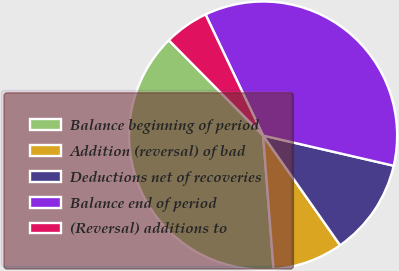Convert chart. <chart><loc_0><loc_0><loc_500><loc_500><pie_chart><fcel>Balance beginning of period<fcel>Addition (reversal) of bad<fcel>Deductions net of recoveries<fcel>Balance end of period<fcel>(Reversal) additions to<nl><fcel>38.83%<fcel>8.5%<fcel>11.64%<fcel>35.68%<fcel>5.35%<nl></chart> 